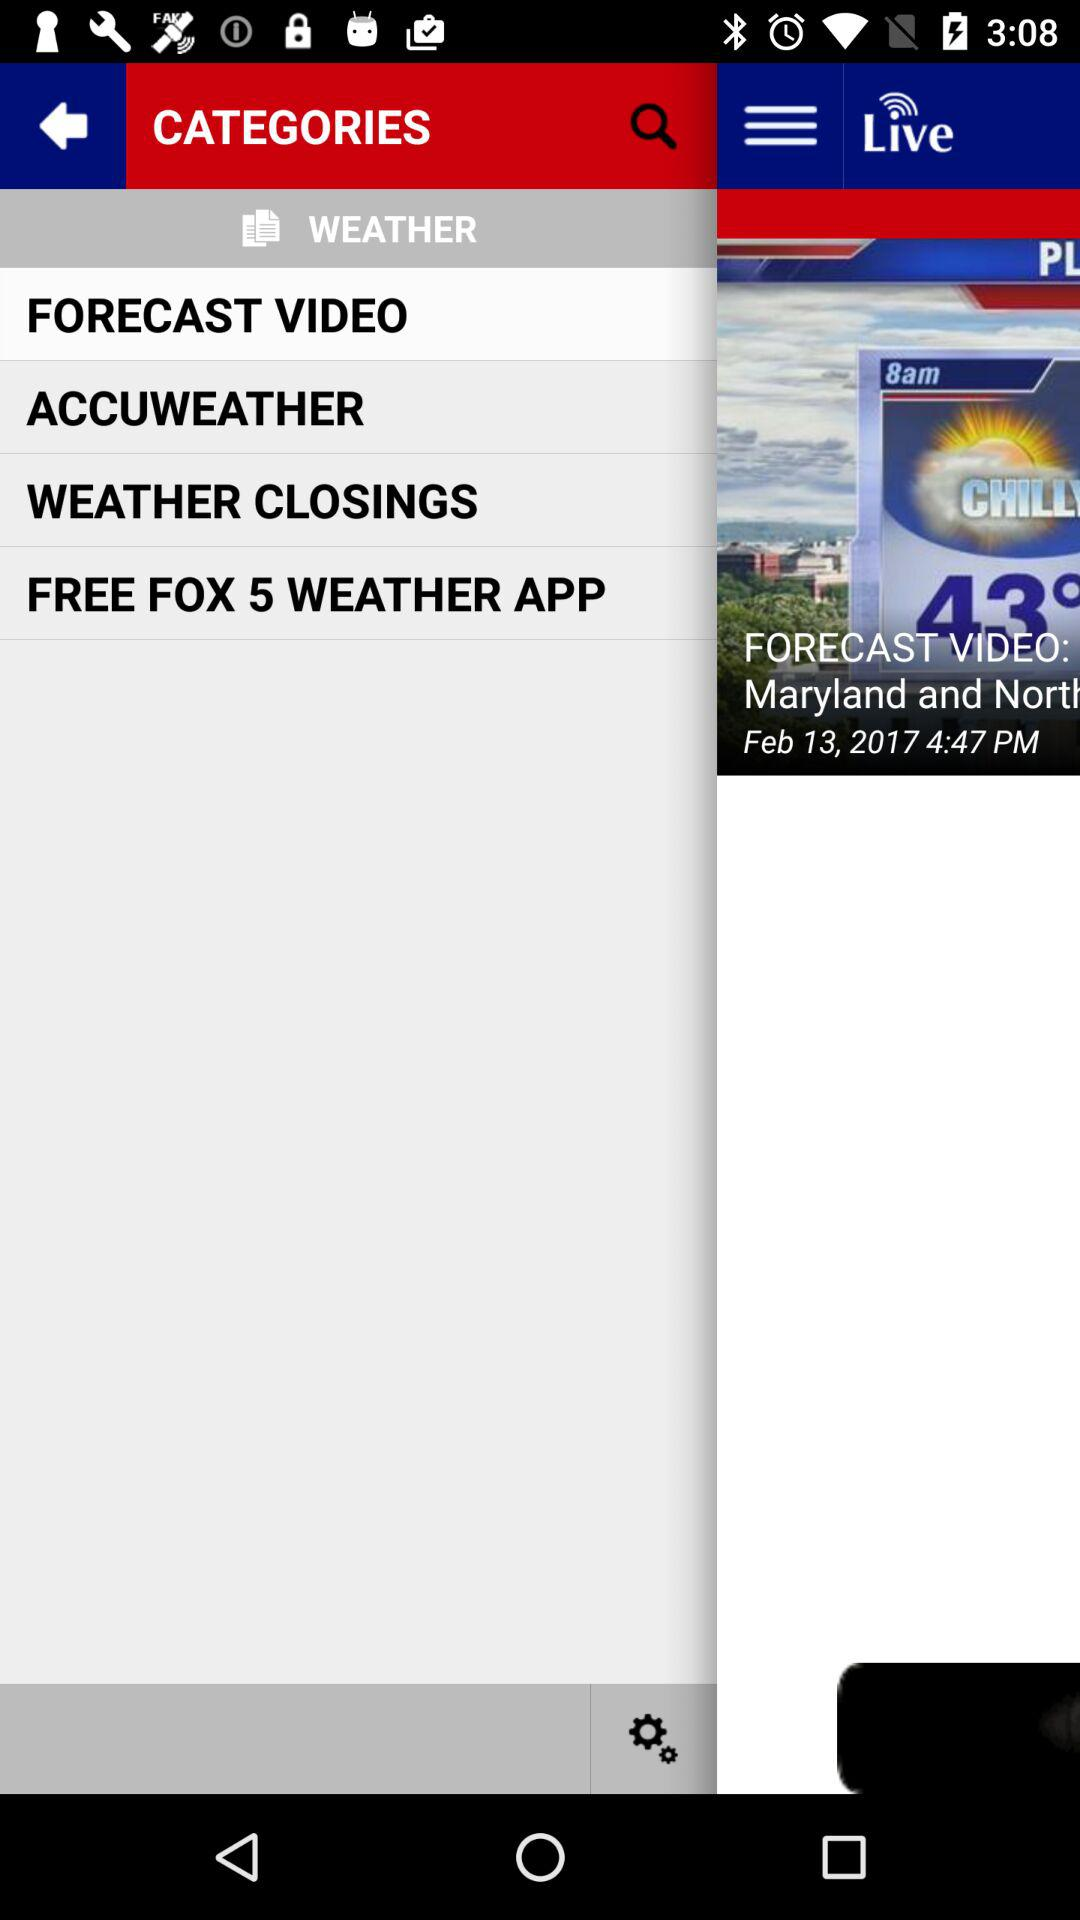What is the name of the application? The name of the application is "FOX 5 WEATHER". 